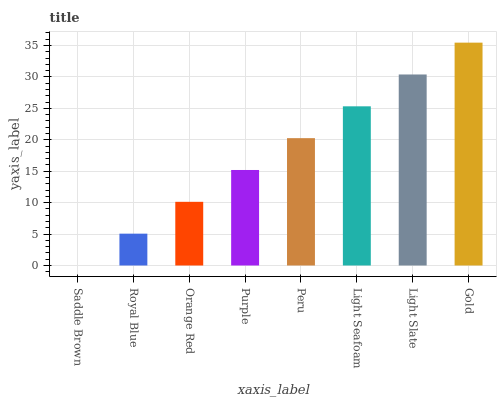Is Saddle Brown the minimum?
Answer yes or no. Yes. Is Gold the maximum?
Answer yes or no. Yes. Is Royal Blue the minimum?
Answer yes or no. No. Is Royal Blue the maximum?
Answer yes or no. No. Is Royal Blue greater than Saddle Brown?
Answer yes or no. Yes. Is Saddle Brown less than Royal Blue?
Answer yes or no. Yes. Is Saddle Brown greater than Royal Blue?
Answer yes or no. No. Is Royal Blue less than Saddle Brown?
Answer yes or no. No. Is Peru the high median?
Answer yes or no. Yes. Is Purple the low median?
Answer yes or no. Yes. Is Light Slate the high median?
Answer yes or no. No. Is Orange Red the low median?
Answer yes or no. No. 